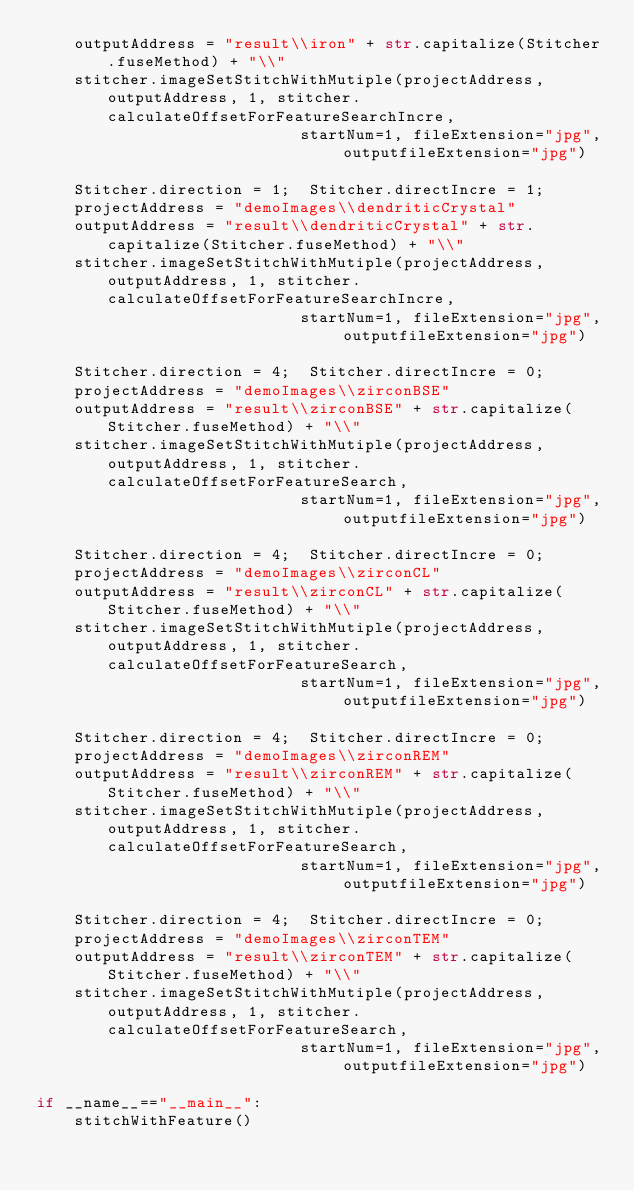Convert code to text. <code><loc_0><loc_0><loc_500><loc_500><_Python_>    outputAddress = "result\\iron" + str.capitalize(Stitcher.fuseMethod) + "\\"
    stitcher.imageSetStitchWithMutiple(projectAddress, outputAddress, 1, stitcher.calculateOffsetForFeatureSearchIncre,
                            startNum=1, fileExtension="jpg", outputfileExtension="jpg")

    Stitcher.direction = 1;  Stitcher.directIncre = 1;
    projectAddress = "demoImages\\dendriticCrystal"
    outputAddress = "result\\dendriticCrystal" + str.capitalize(Stitcher.fuseMethod) + "\\"
    stitcher.imageSetStitchWithMutiple(projectAddress, outputAddress, 1, stitcher.calculateOffsetForFeatureSearchIncre,
                            startNum=1, fileExtension="jpg", outputfileExtension="jpg")

    Stitcher.direction = 4;  Stitcher.directIncre = 0;
    projectAddress = "demoImages\\zirconBSE"
    outputAddress = "result\\zirconBSE" + str.capitalize(Stitcher.fuseMethod) + "\\"
    stitcher.imageSetStitchWithMutiple(projectAddress, outputAddress, 1, stitcher.calculateOffsetForFeatureSearch,
                            startNum=1, fileExtension="jpg", outputfileExtension="jpg")

    Stitcher.direction = 4;  Stitcher.directIncre = 0;
    projectAddress = "demoImages\\zirconCL"
    outputAddress = "result\\zirconCL" + str.capitalize(Stitcher.fuseMethod) + "\\"
    stitcher.imageSetStitchWithMutiple(projectAddress, outputAddress, 1, stitcher.calculateOffsetForFeatureSearch,
                            startNum=1, fileExtension="jpg", outputfileExtension="jpg")

    Stitcher.direction = 4;  Stitcher.directIncre = 0;
    projectAddress = "demoImages\\zirconREM"
    outputAddress = "result\\zirconREM" + str.capitalize(Stitcher.fuseMethod) + "\\"
    stitcher.imageSetStitchWithMutiple(projectAddress, outputAddress, 1, stitcher.calculateOffsetForFeatureSearch,
                            startNum=1, fileExtension="jpg", outputfileExtension="jpg")

    Stitcher.direction = 4;  Stitcher.directIncre = 0;
    projectAddress = "demoImages\\zirconTEM"
    outputAddress = "result\\zirconTEM" + str.capitalize(Stitcher.fuseMethod) + "\\"
    stitcher.imageSetStitchWithMutiple(projectAddress, outputAddress, 1, stitcher.calculateOffsetForFeatureSearch,
                            startNum=1, fileExtension="jpg", outputfileExtension="jpg")

if __name__=="__main__":
    stitchWithFeature()
</code> 